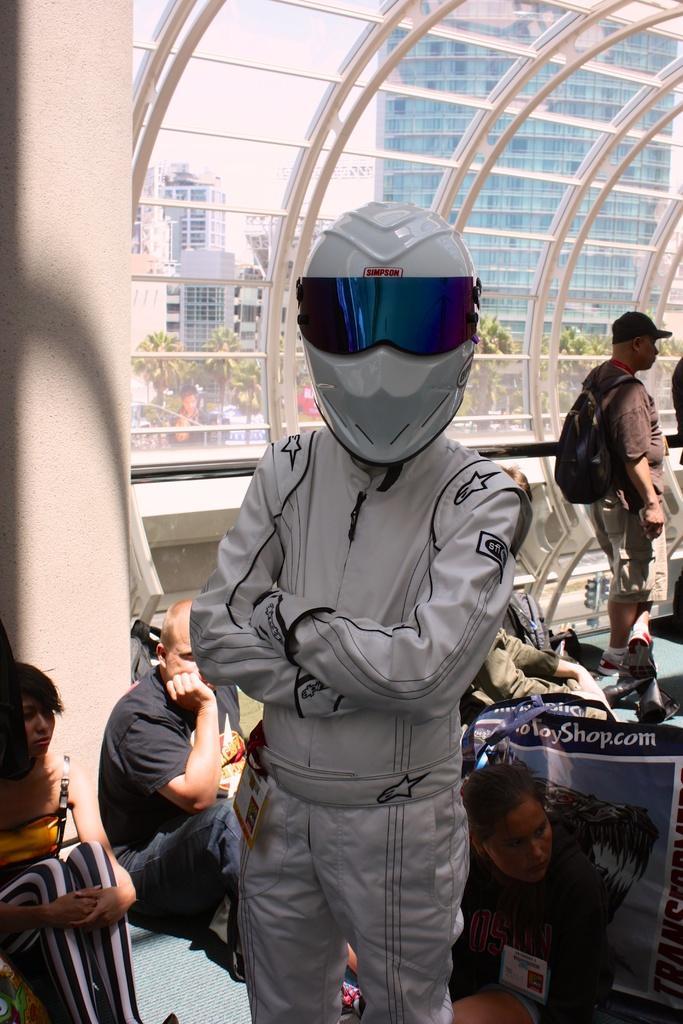Describe this image in one or two sentences. This picture describes about group of people, few are seated and few are standing, in the middle of the image we can see a person and the person wore a helmet, behind the person we can see few trees, buildings and glasses. 